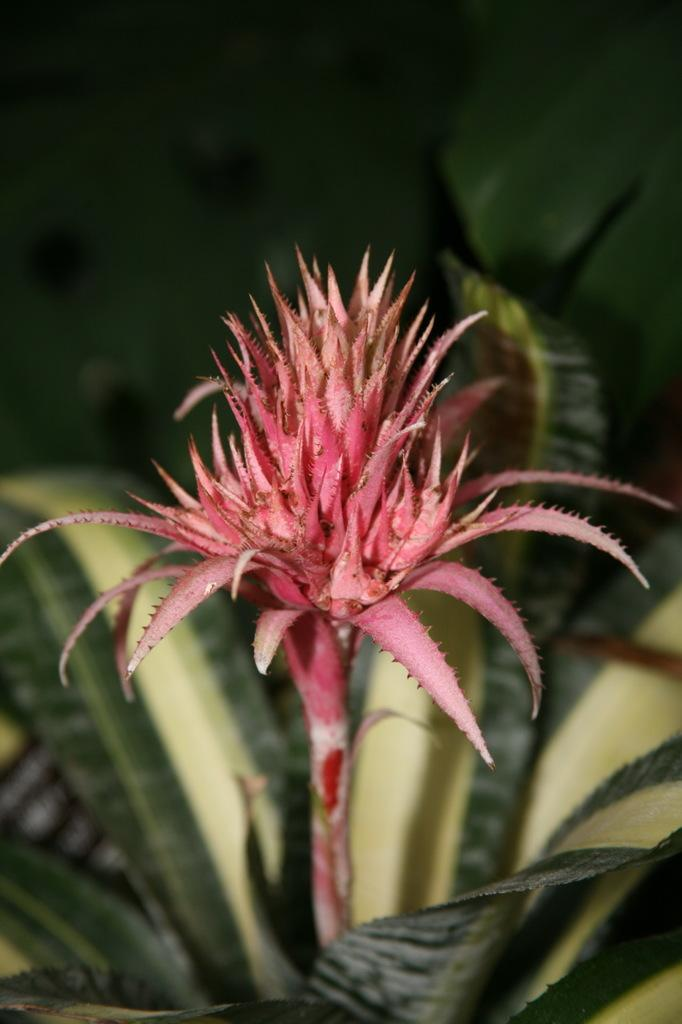What is the main subject in the center of the image? There is a flower in the center of the image. What type of vegetation is present at the bottom of the image? There are leaves at the bottom of the image. What type of band is playing in the background of the image? There is no band present in the image; it features a flower and leaves. What is the height of the governor in the image? There is no governor present in the image. 